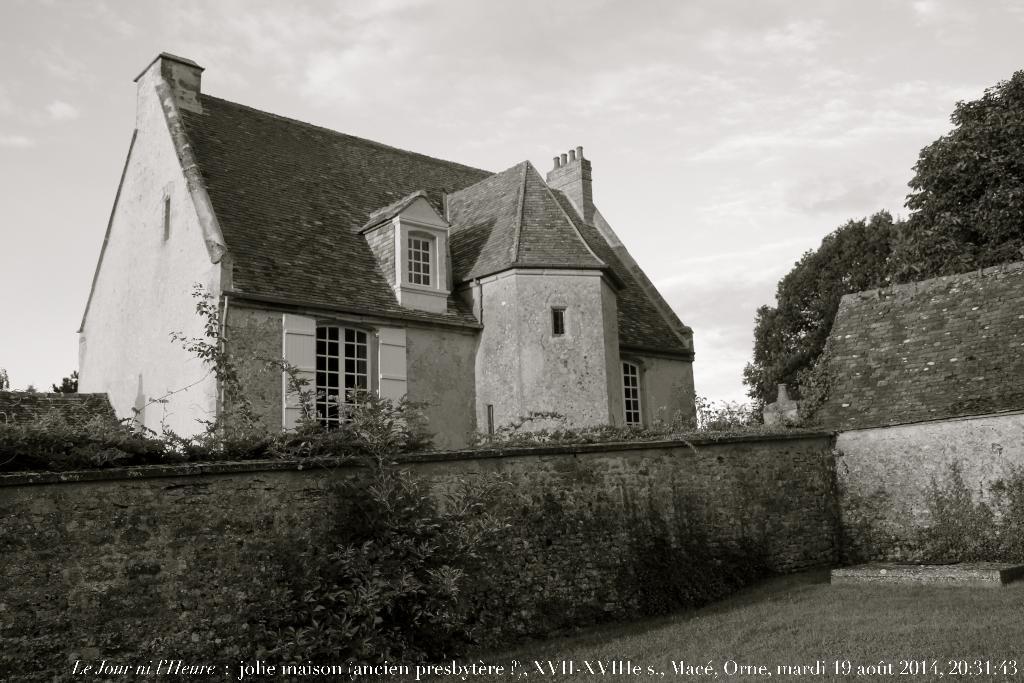Could you give a brief overview of what you see in this image? In this image I can see few trees, a building and sky, and the image is in black and white. 